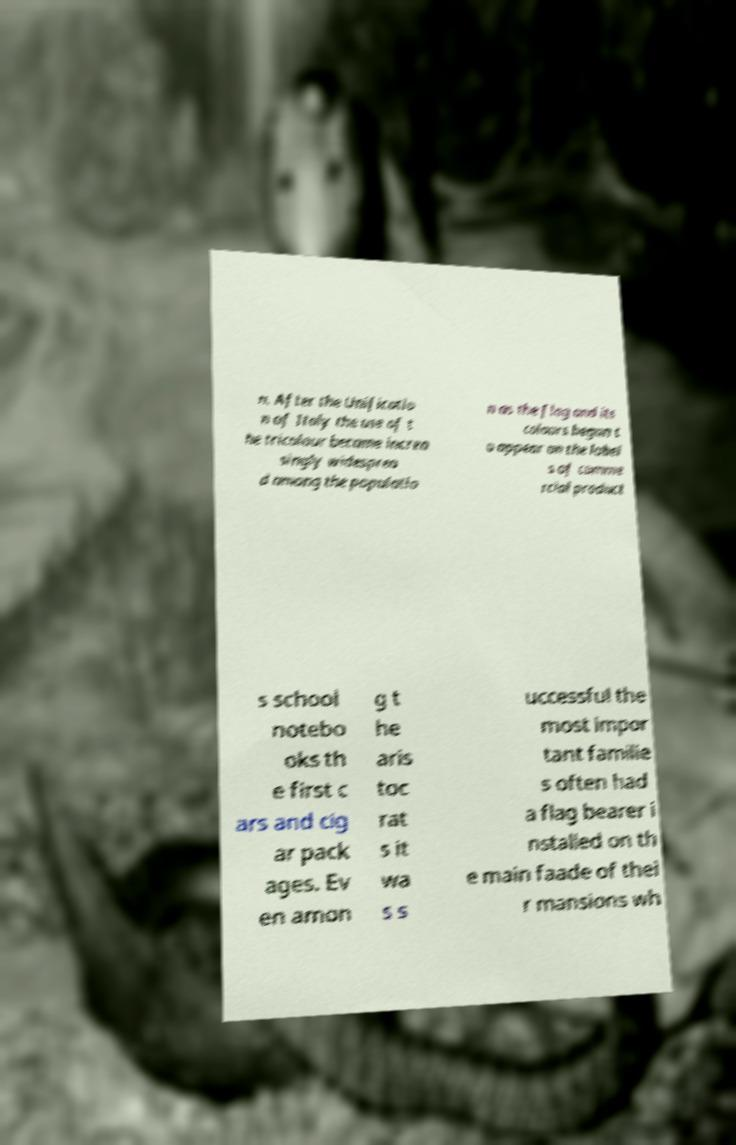Please identify and transcribe the text found in this image. n. After the Unificatio n of Italy the use of t he tricolour became increa singly widesprea d among the populatio n as the flag and its colours began t o appear on the label s of comme rcial product s school notebo oks th e first c ars and cig ar pack ages. Ev en amon g t he aris toc rat s it wa s s uccessful the most impor tant familie s often had a flag bearer i nstalled on th e main faade of thei r mansions wh 